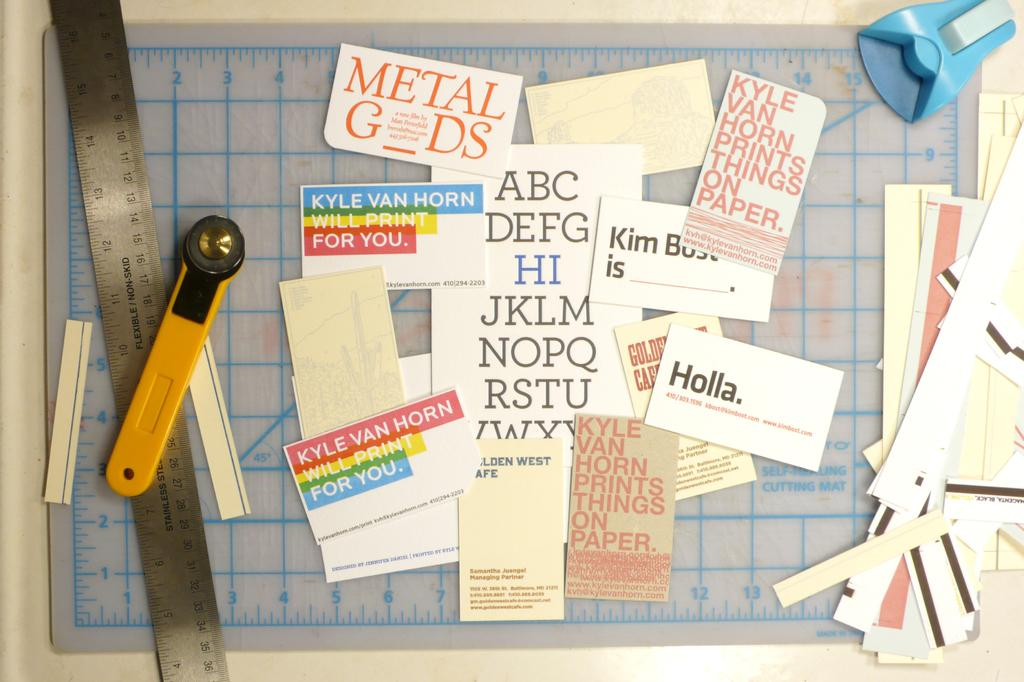<image>
Give a short and clear explanation of the subsequent image. A flexible/non-skid stainless steel ruler beside several business cards. 